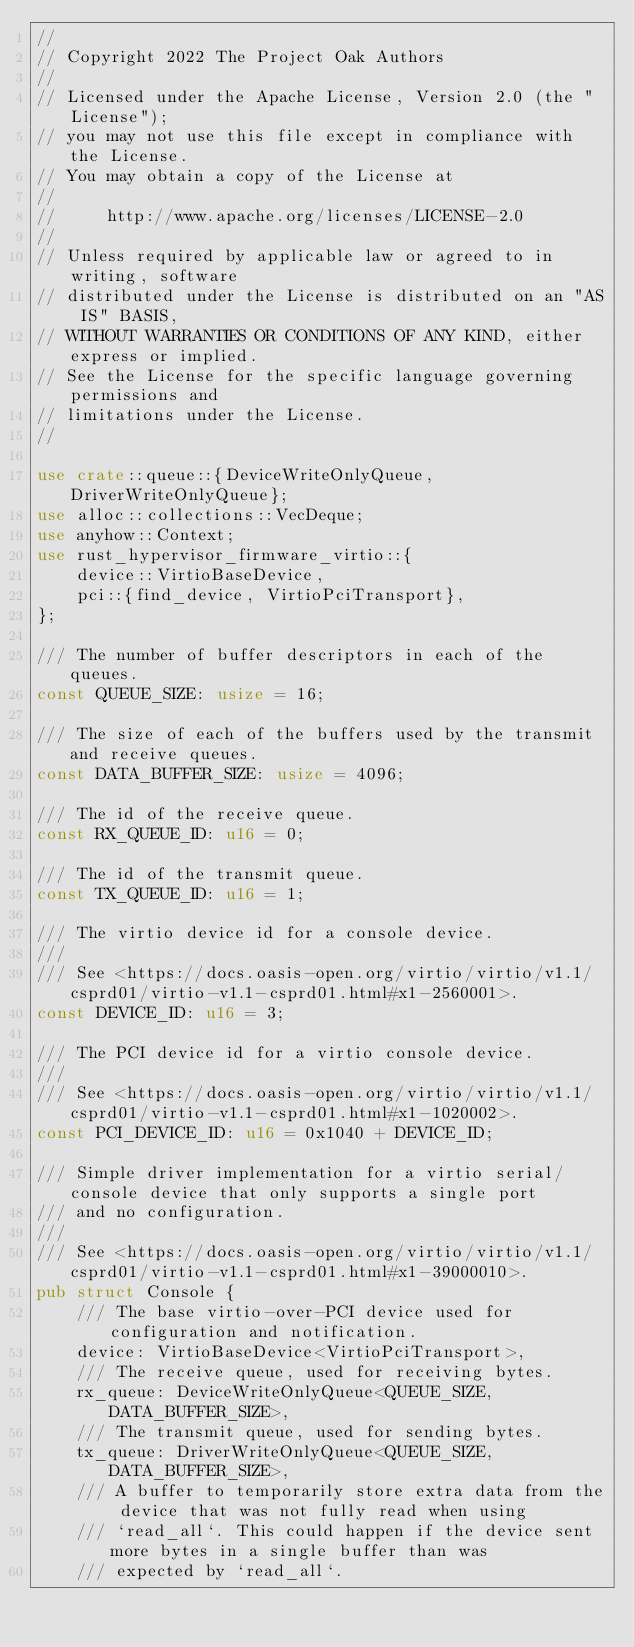Convert code to text. <code><loc_0><loc_0><loc_500><loc_500><_Rust_>//
// Copyright 2022 The Project Oak Authors
//
// Licensed under the Apache License, Version 2.0 (the "License");
// you may not use this file except in compliance with the License.
// You may obtain a copy of the License at
//
//     http://www.apache.org/licenses/LICENSE-2.0
//
// Unless required by applicable law or agreed to in writing, software
// distributed under the License is distributed on an "AS IS" BASIS,
// WITHOUT WARRANTIES OR CONDITIONS OF ANY KIND, either express or implied.
// See the License for the specific language governing permissions and
// limitations under the License.
//

use crate::queue::{DeviceWriteOnlyQueue, DriverWriteOnlyQueue};
use alloc::collections::VecDeque;
use anyhow::Context;
use rust_hypervisor_firmware_virtio::{
    device::VirtioBaseDevice,
    pci::{find_device, VirtioPciTransport},
};

/// The number of buffer descriptors in each of the queues.
const QUEUE_SIZE: usize = 16;

/// The size of each of the buffers used by the transmit and receive queues.
const DATA_BUFFER_SIZE: usize = 4096;

/// The id of the receive queue.
const RX_QUEUE_ID: u16 = 0;

/// The id of the transmit queue.
const TX_QUEUE_ID: u16 = 1;

/// The virtio device id for a console device.
///
/// See <https://docs.oasis-open.org/virtio/virtio/v1.1/csprd01/virtio-v1.1-csprd01.html#x1-2560001>.
const DEVICE_ID: u16 = 3;

/// The PCI device id for a virtio console device.
///
/// See <https://docs.oasis-open.org/virtio/virtio/v1.1/csprd01/virtio-v1.1-csprd01.html#x1-1020002>.
const PCI_DEVICE_ID: u16 = 0x1040 + DEVICE_ID;

/// Simple driver implementation for a virtio serial/console device that only supports a single port
/// and no configuration.
///
/// See <https://docs.oasis-open.org/virtio/virtio/v1.1/csprd01/virtio-v1.1-csprd01.html#x1-39000010>.
pub struct Console {
    /// The base virtio-over-PCI device used for configuration and notification.
    device: VirtioBaseDevice<VirtioPciTransport>,
    /// The receive queue, used for receiving bytes.
    rx_queue: DeviceWriteOnlyQueue<QUEUE_SIZE, DATA_BUFFER_SIZE>,
    /// The transmit queue, used for sending bytes.
    tx_queue: DriverWriteOnlyQueue<QUEUE_SIZE, DATA_BUFFER_SIZE>,
    /// A buffer to temporarily store extra data from the device that was not fully read when using
    /// `read_all`. This could happen if the device sent more bytes in a single buffer than was
    /// expected by `read_all`.</code> 